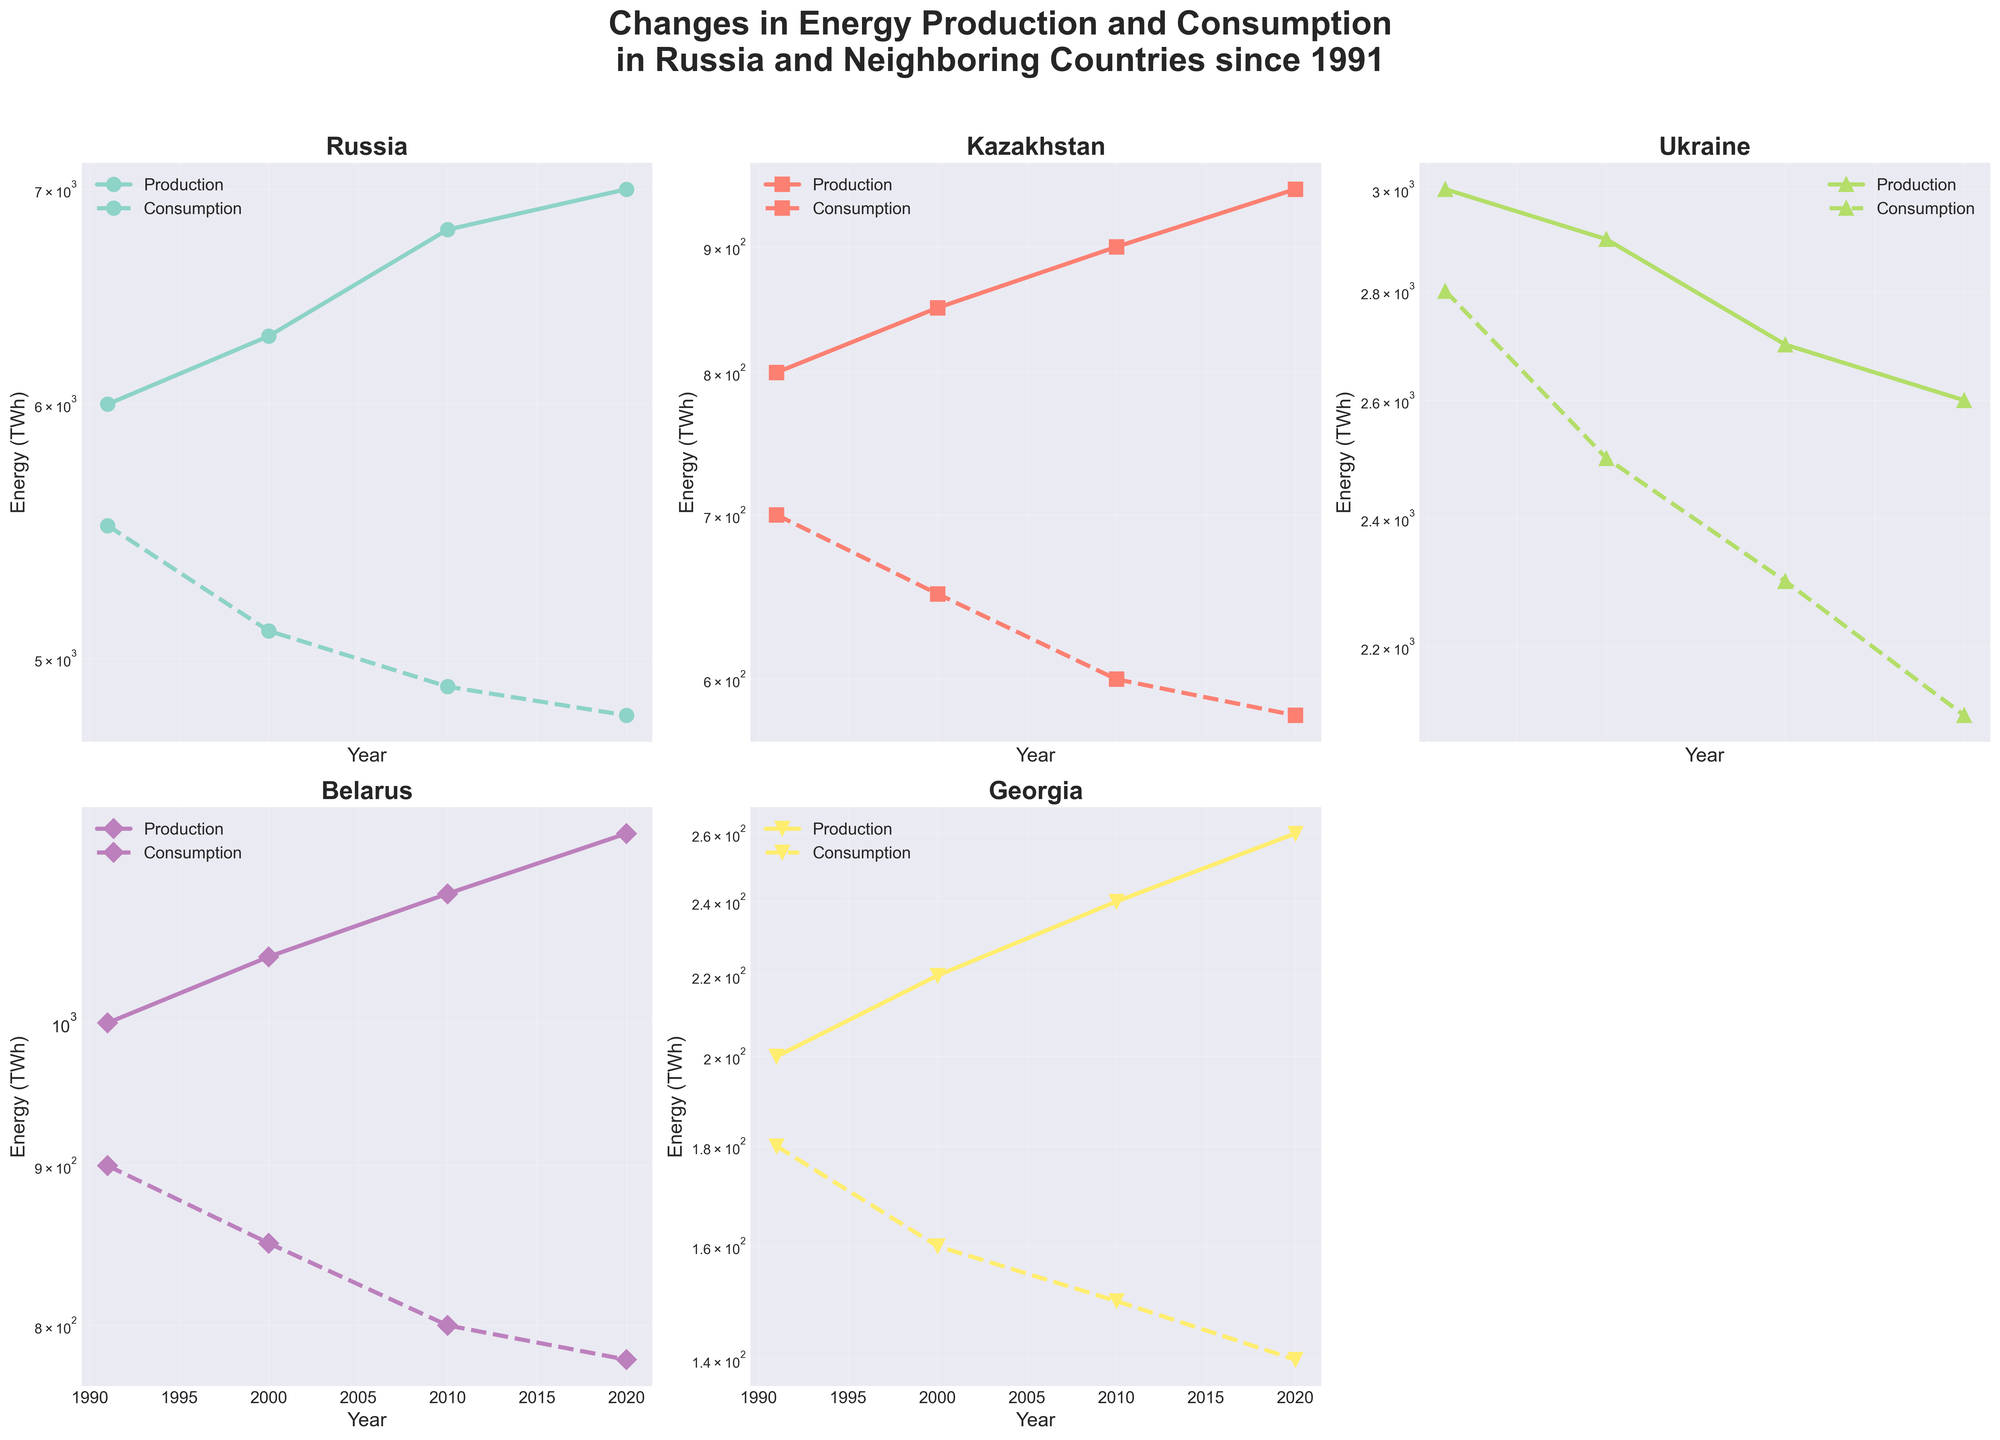What is the range of years shown for energy production and consumption trends in the figure? The x-axis of each subplot represents the year, and the labels show the period covered, which is from 1991 to 2020.
Answer: 1991 to 2020 Which country has the highest energy production in 2020? By examining the endpoints of the energy production lines for the year 2020 across subplots, the subplot for Russia shows the highest production value.
Answer: Russia How does the energy consumption trend in Kazakhstan compare to the trend in Belarus from 1991 to 2020? Observing both subplots, Kazakhstan's energy consumption shows a decreasing trend from 700 TWh to 580 TWh, while Belarus's consumption decreases from 900 TWh to 780 TWh. Both countries show a decrease, but Kazakhstan's consumption decrease is more pronounced.
Answer: Both decreased, Kazakhstan more pronounced In which year did Russia's energy production first surpass 6800 TWh? By looking at the production line in the Russia subplot, the energy production surpasses 6800 TWh in the year 2010.
Answer: 2010 What is the trend of energy consumption in Ukraine from 1991 to 2020? In the Ukraine subplot, the energy consumption consistently decreases from 2800 TWh in 1991 to 2100 TWh in 2020.
Answer: Decreasing Which country shows the smallest gap between energy production and consumption in 1991? Comparing the gaps in each subplot for 1991, Georgia shows the smallest difference between 200 TWh production and 180 TWh consumption, a gap of 20 TWh.
Answer: Georgia Between 2000 and 2010, which country exhibited the greatest increase in energy production? By examining the energy production lines between 2000 and 2010, Russia’s production increases from 6300 TWh to 6800 TWh, which is an increase of 500 TWh, greater than any other country.
Answer: Russia What is the relative change in energy consumption for Belarus from 1991 to 2020? Belarus's energy consumption decreases from 900 TWh in 1991 to 780 TWh in 2020. The relative change can be calculated as (900 - 780) / 900 * 100 = 13.33%.
Answer: -13.33% Looking at the log scale, which country's energy production demonstrates the most consistent increase over the years? On a logarithmic scale, a consistent increase appears as an almost straight, gently rising line. Russia's energy production shows a steady and smooth increase compared to other countries.
Answer: Russia 